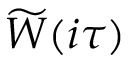<formula> <loc_0><loc_0><loc_500><loc_500>\widetilde { W } ( i \tau )</formula> 